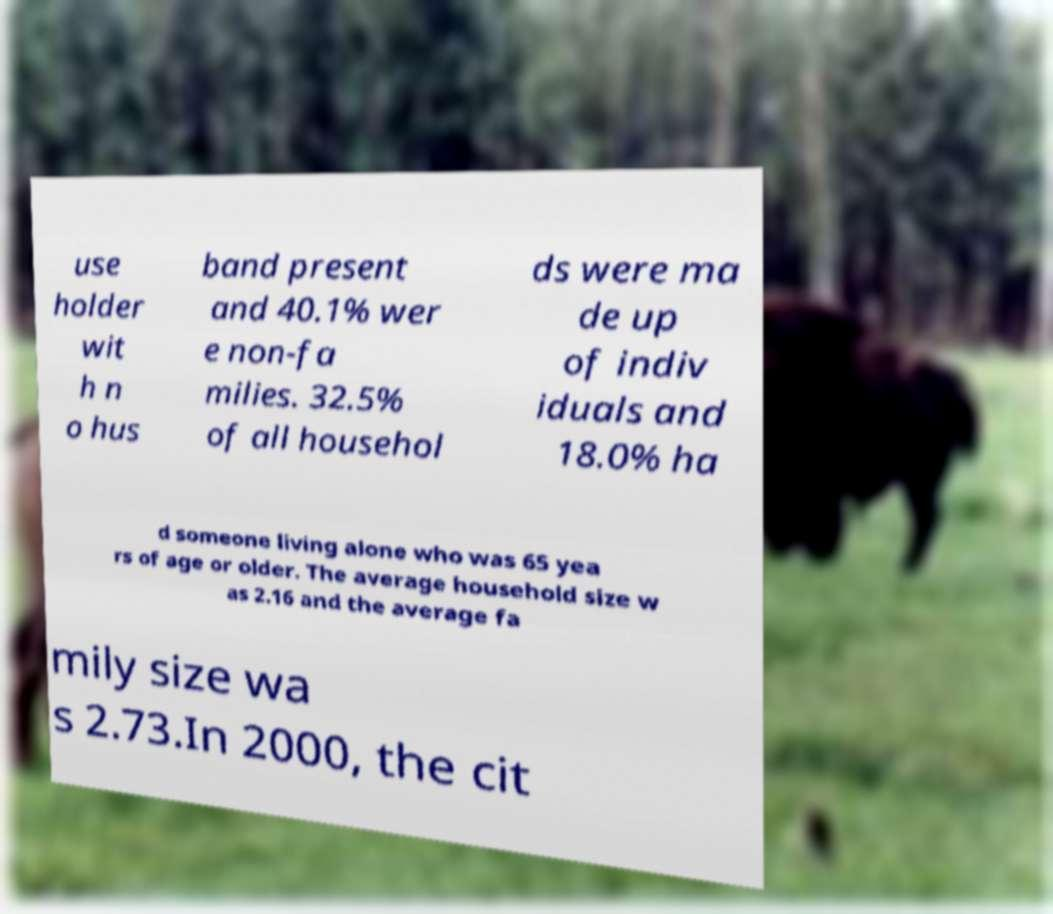Can you accurately transcribe the text from the provided image for me? use holder wit h n o hus band present and 40.1% wer e non-fa milies. 32.5% of all househol ds were ma de up of indiv iduals and 18.0% ha d someone living alone who was 65 yea rs of age or older. The average household size w as 2.16 and the average fa mily size wa s 2.73.In 2000, the cit 